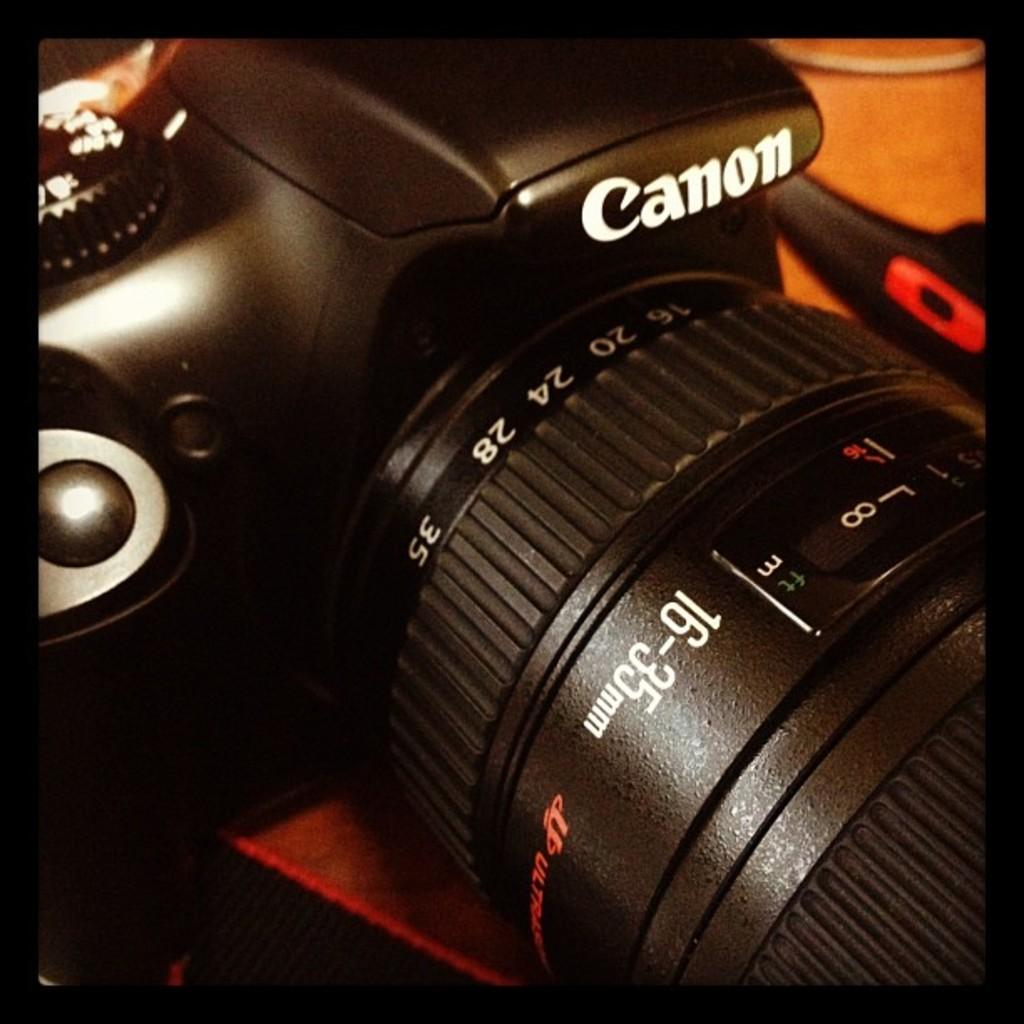What is the main subject of the image? The main subject of the image is a camera. Can you describe any other objects in the image? There is an unspecified object beside the camera. What type of mask is being worn by the person in the image? There is no person present in the image, and therefore no mask can be observed. 